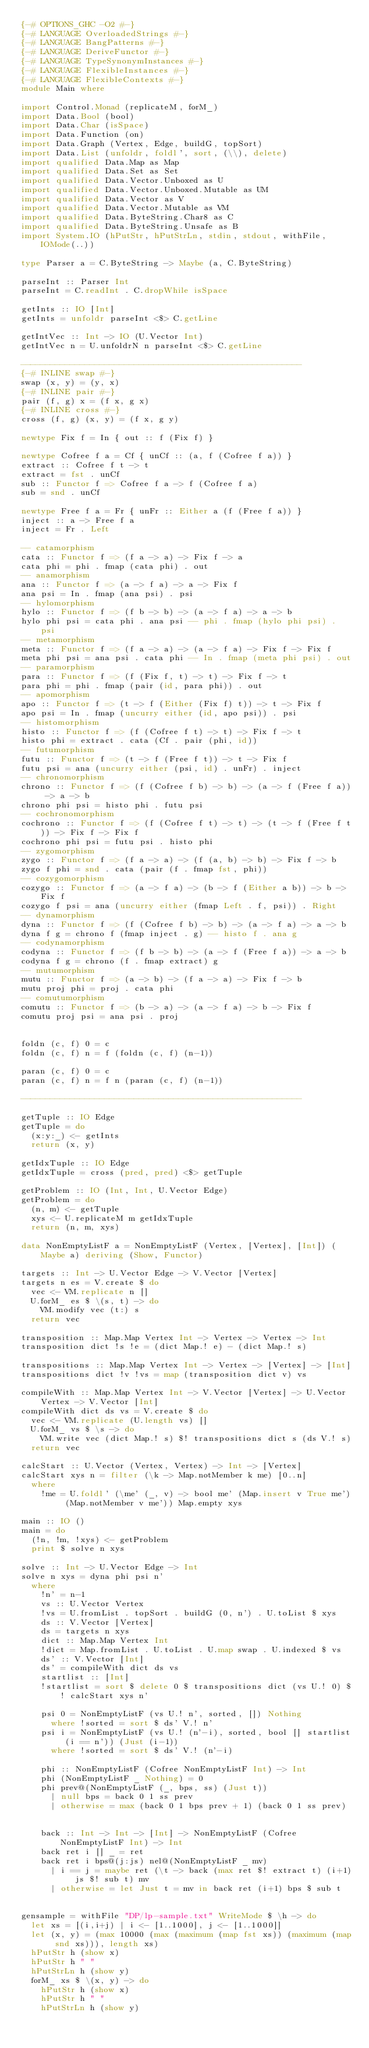Convert code to text. <code><loc_0><loc_0><loc_500><loc_500><_Haskell_>{-# OPTIONS_GHC -O2 #-}
{-# LANGUAGE OverloadedStrings #-}
{-# LANGUAGE BangPatterns #-}
{-# LANGUAGE DeriveFunctor #-}
{-# LANGUAGE TypeSynonymInstances #-}
{-# LANGUAGE FlexibleInstances #-}
{-# LANGUAGE FlexibleContexts #-}
module Main where

import Control.Monad (replicateM, forM_)
import Data.Bool (bool)
import Data.Char (isSpace)
import Data.Function (on)
import Data.Graph (Vertex, Edge, buildG, topSort)
import Data.List (unfoldr, foldl', sort, (\\), delete)
import qualified Data.Map as Map
import qualified Data.Set as Set
import qualified Data.Vector.Unboxed as U
import qualified Data.Vector.Unboxed.Mutable as UM
import qualified Data.Vector as V
import qualified Data.Vector.Mutable as VM
import qualified Data.ByteString.Char8 as C
import qualified Data.ByteString.Unsafe as B
import System.IO (hPutStr, hPutStrLn, stdin, stdout, withFile, IOMode(..))

type Parser a = C.ByteString -> Maybe (a, C.ByteString)

parseInt :: Parser Int
parseInt = C.readInt . C.dropWhile isSpace

getInts :: IO [Int]
getInts = unfoldr parseInt <$> C.getLine

getIntVec :: Int -> IO (U.Vector Int)
getIntVec n = U.unfoldrN n parseInt <$> C.getLine

---------------------------------------------------------
{-# INLINE swap #-}
swap (x, y) = (y, x)
{-# INLINE pair #-}
pair (f, g) x = (f x, g x)
{-# INLINE cross #-}
cross (f, g) (x, y) = (f x, g y)

newtype Fix f = In { out :: f (Fix f) }

newtype Cofree f a = Cf { unCf :: (a, f (Cofree f a)) }
extract :: Cofree f t -> t
extract = fst . unCf
sub :: Functor f => Cofree f a -> f (Cofree f a)
sub = snd . unCf

newtype Free f a = Fr { unFr :: Either a (f (Free f a)) }
inject :: a -> Free f a
inject = Fr . Left

-- catamorphism
cata :: Functor f => (f a -> a) -> Fix f -> a
cata phi = phi . fmap (cata phi) . out
-- anamorphism
ana :: Functor f => (a -> f a) -> a -> Fix f
ana psi = In . fmap (ana psi) . psi
-- hylomorphism
hylo :: Functor f => (f b -> b) -> (a -> f a) -> a -> b
hylo phi psi = cata phi . ana psi -- phi . fmap (hylo phi psi) . psi
-- metamorphism
meta :: Functor f => (f a -> a) -> (a -> f a) -> Fix f -> Fix f
meta phi psi = ana psi . cata phi -- In . fmap (meta phi psi) . out
-- paramorphism
para :: Functor f => (f (Fix f, t) -> t) -> Fix f -> t
para phi = phi . fmap (pair (id, para phi)) . out
-- apomorphism
apo :: Functor f => (t -> f (Either (Fix f) t)) -> t -> Fix f
apo psi = In . fmap (uncurry either (id, apo psi)) . psi
-- histomorphism
histo :: Functor f => (f (Cofree f t) -> t) -> Fix f -> t
histo phi = extract . cata (Cf . pair (phi, id))
-- futumorphism
futu :: Functor f => (t -> f (Free f t)) -> t -> Fix f
futu psi = ana (uncurry either (psi, id) . unFr) . inject
-- chronomorphism
chrono :: Functor f => (f (Cofree f b) -> b) -> (a -> f (Free f a)) -> a -> b
chrono phi psi = histo phi . futu psi
-- cochronomorphism
cochrono :: Functor f => (f (Cofree f t) -> t) -> (t -> f (Free f t)) -> Fix f -> Fix f
cochrono phi psi = futu psi . histo phi
-- zygomorphism
zygo :: Functor f => (f a -> a) -> (f (a, b) -> b) -> Fix f -> b
zygo f phi = snd . cata (pair (f . fmap fst, phi))
-- cozygomorphism
cozygo :: Functor f => (a -> f a) -> (b -> f (Either a b)) -> b -> Fix f
cozygo f psi = ana (uncurry either (fmap Left . f, psi)) . Right
-- dynamorphism
dyna :: Functor f => (f (Cofree f b) -> b) -> (a -> f a) -> a -> b
dyna f g = chrono f (fmap inject . g) -- histo f . ana g
-- codynamorphism
codyna :: Functor f => (f b -> b) -> (a -> f (Free f a)) -> a -> b
codyna f g = chrono (f . fmap extract) g
-- mutumorphism
mutu :: Functor f => (a -> b) -> (f a -> a) -> Fix f -> b
mutu proj phi = proj . cata phi
-- comutumorphism
comutu :: Functor f => (b -> a) -> (a -> f a) -> b -> Fix f
comutu proj psi = ana psi . proj


foldn (c, f) 0 = c
foldn (c, f) n = f (foldn (c, f) (n-1))

paran (c, f) 0 = c
paran (c, f) n = f n (paran (c, f) (n-1))

---------------------------------------------------------

getTuple :: IO Edge
getTuple = do
  (x:y:_) <- getInts
  return (x, y)

getIdxTuple :: IO Edge
getIdxTuple = cross (pred, pred) <$> getTuple

getProblem :: IO (Int, Int, U.Vector Edge)
getProblem = do
  (n, m) <- getTuple
  xys <- U.replicateM m getIdxTuple
  return (n, m, xys)

data NonEmptyListF a = NonEmptyListF (Vertex, [Vertex], [Int]) (Maybe a) deriving (Show, Functor)

targets :: Int -> U.Vector Edge -> V.Vector [Vertex]
targets n es = V.create $ do
  vec <- VM.replicate n []
  U.forM_ es $ \(s, t) -> do
    VM.modify vec (t:) s
  return vec

transposition :: Map.Map Vertex Int -> Vertex -> Vertex -> Int
transposition dict !s !e = (dict Map.! e) - (dict Map.! s)

transpositions :: Map.Map Vertex Int -> Vertex -> [Vertex] -> [Int]
transpositions dict !v !vs = map (transposition dict v) vs

compileWith :: Map.Map Vertex Int -> V.Vector [Vertex] -> U.Vector Vertex -> V.Vector [Int]
compileWith dict ds vs = V.create $ do
  vec <- VM.replicate (U.length vs) []
  U.forM_ vs $ \s -> do
    VM.write vec (dict Map.! s) $! transpositions dict s (ds V.! s)
  return vec

calcStart :: U.Vector (Vertex, Vertex) -> Int -> [Vertex]
calcStart xys n = filter (\k -> Map.notMember k me) [0..n]
  where
    !me = U.foldl' (\me' (_, v) -> bool me' (Map.insert v True me') (Map.notMember v me')) Map.empty xys

main :: IO ()
main = do
  (!n, !m, !xys) <- getProblem
  print $ solve n xys

solve :: Int -> U.Vector Edge -> Int
solve n xys = dyna phi psi n'
  where
    !n' = n-1
    vs :: U.Vector Vertex
    !vs = U.fromList . topSort . buildG (0, n') . U.toList $ xys
    ds :: V.Vector [Vertex]
    ds = targets n xys
    dict :: Map.Map Vertex Int
    !dict = Map.fromList . U.toList . U.map swap . U.indexed $ vs
    ds' :: V.Vector [Int]
    ds' = compileWith dict ds vs
    startlist :: [Int]
    !startlist = sort $ delete 0 $ transpositions dict (vs U.! 0) $! calcStart xys n'
    
    psi 0 = NonEmptyListF (vs U.! n', sorted, []) Nothing
      where !sorted = sort $ ds' V.! n'
    psi i = NonEmptyListF (vs U.! (n'-i), sorted, bool [] startlist (i == n')) (Just (i-1))
      where !sorted = sort $ ds' V.! (n'-i)

    phi :: NonEmptyListF (Cofree NonEmptyListF Int) -> Int
    phi (NonEmptyListF _ Nothing) = 0
    phi prev@(NonEmptyListF (_, bps, ss) (Just t))
      | null bps = back 0 1 ss prev
      | otherwise = max (back 0 1 bps prev + 1) (back 0 1 ss prev)


    back :: Int -> Int -> [Int] -> NonEmptyListF (Cofree NonEmptyListF Int) -> Int
    back ret i [] _ = ret
    back ret i bps@(j:js) nel@(NonEmptyListF _ mv)
      | i == j = maybe ret (\t -> back (max ret $! extract t) (i+1) js $! sub t) mv
      | otherwise = let Just t = mv in back ret (i+1) bps $ sub t


gensample = withFile "DP/lp-sample.txt" WriteMode $ \h -> do
  let xs = [(i,i+j) | i <- [1..1000], j <- [1..1000]]
  let (x, y) = (max 10000 (max (maximum (map fst xs)) (maximum (map snd xs))), length xs)
  hPutStr h (show x)
  hPutStr h " "
  hPutStrLn h (show y)
  forM_ xs $ \(x, y) -> do
    hPutStr h (show x)
    hPutStr h " "
    hPutStrLn h (show y)
</code> 